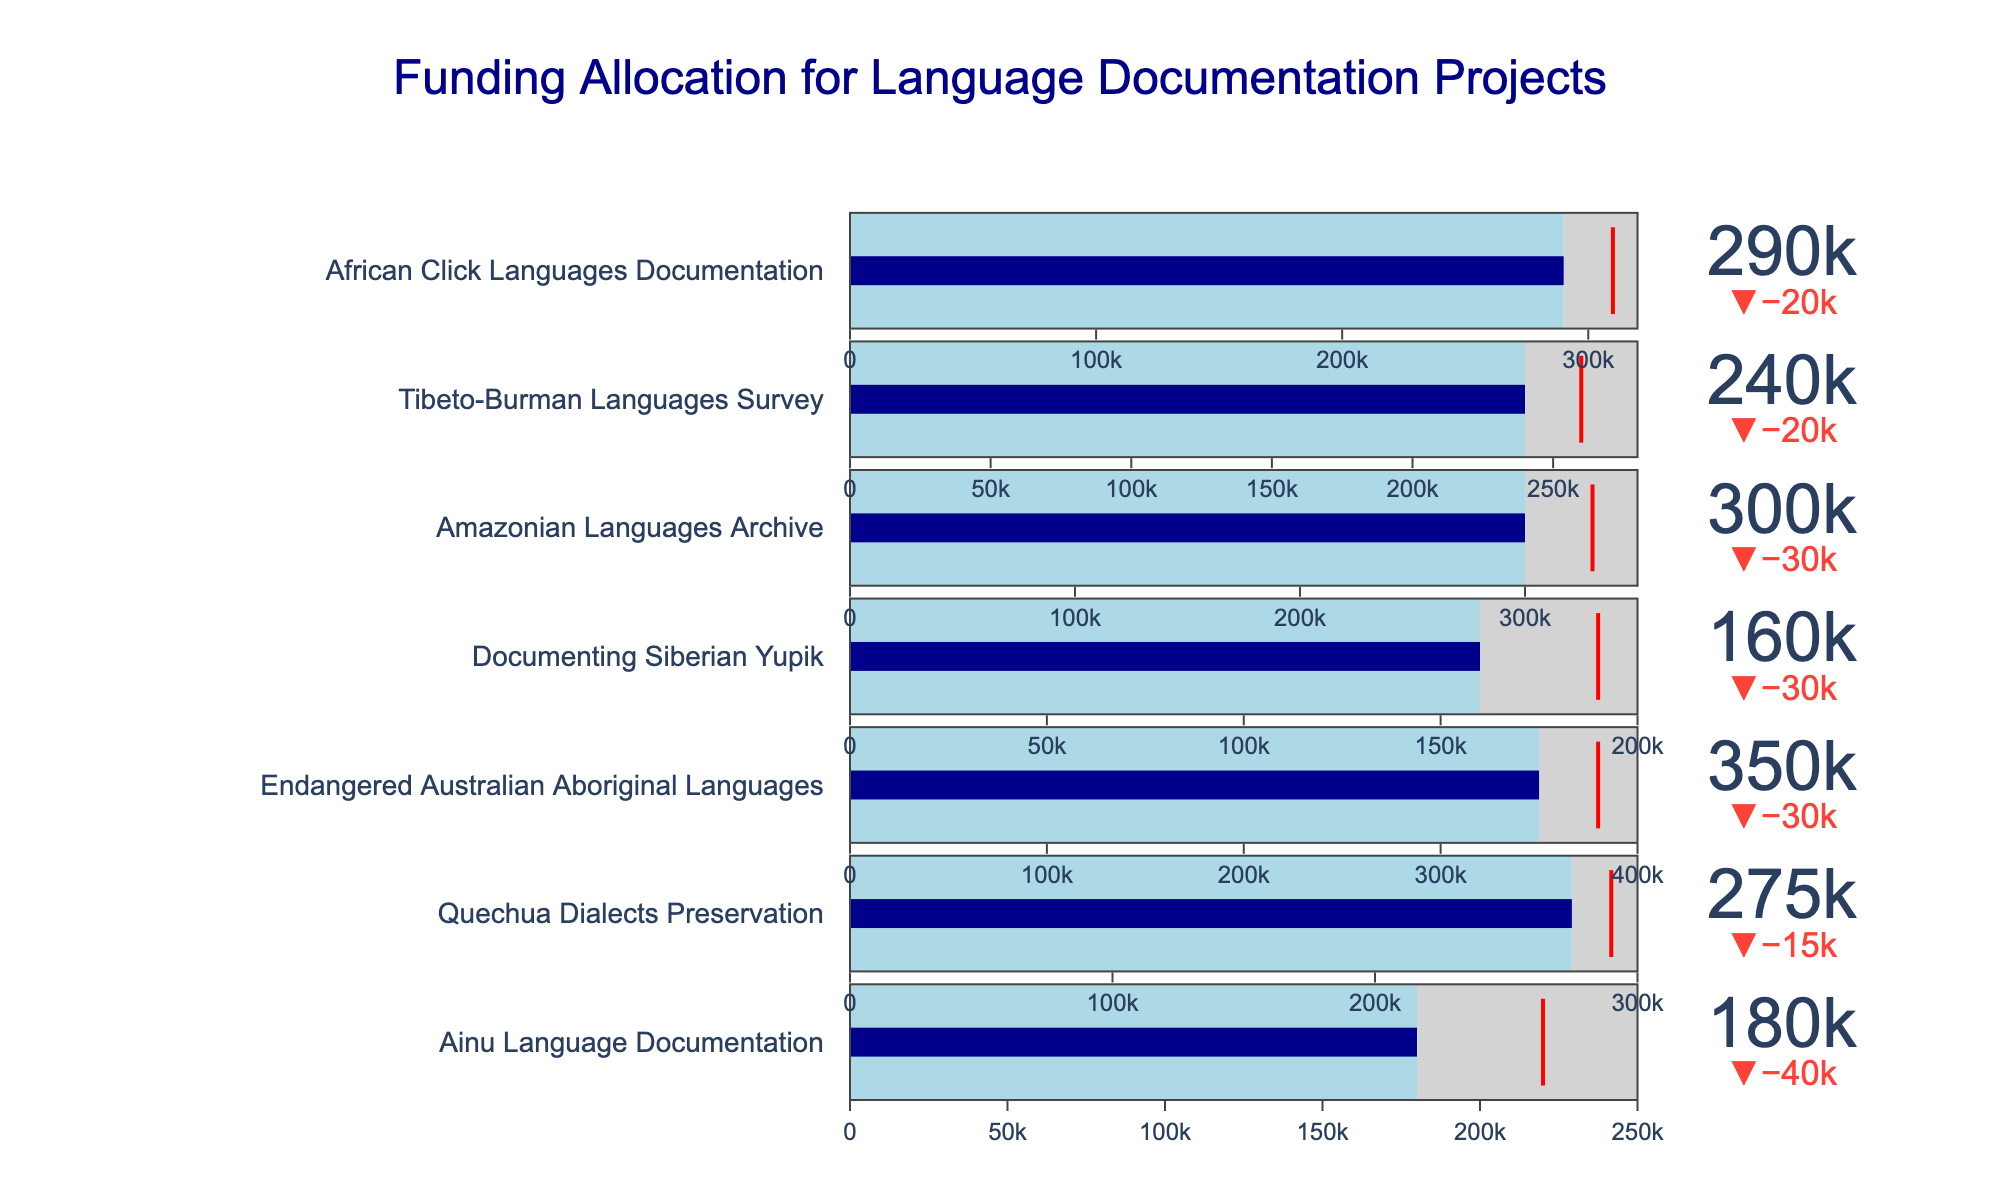How many projects are displayed in the bullet chart? Count the number of individual projects listed in the chart. There are 7 projects shown: Ainu Language Documentation, Quechua Dialects Preservation, Endangered Australian Aboriginal Languages, Documenting Siberian Yupik, Amazonian Languages Archive, Tibeto-Burman Languages Survey, and African Click Languages Documentation.
Answer: 7 Which project received the highest actual funding? Look at the actual funding values for each project and identify the highest one. Endangered Australian Aboriginal Languages received the highest actual funding of $350,000.
Answer: Endangered Australian Aboriginal Languages Which project is closest to its target funding? Calculate the difference between actual funding and target funding for each project, then identify the smallest difference. Quechua Dialects Preservation has the smallest difference of $15,000 ($275,000 actual vs. $290,000 target).
Answer: Quechua Dialects Preservation What is the total proposed budget across all projects? Sum up the Proposed Budget values for all projects: $250,000 + $300,000 + $400,000 + $200,000 + $350,000 + $280,000 + $320,000. The total is $2,100,000.
Answer: $2,100,000 Which projects exceeded their target funding? Compare actual funding to target funding for each project and identify the ones where actual funding is greater than or equal to target funding. No project surpassed its target funding.
Answer: None For the Amazonian Languages Archive, how much less was the actual funding compared to the proposed budget? Subtract the actual funding from the proposed budget for the Amazonian Languages Archive: $350,000 - $300,000 = $50,000.
Answer: $50,000 Which project has the largest gap between its actual funding and proposed budget? Calculate the difference between actual funding and proposed budget for all projects and identify the largest difference. Endangered Australian Aboriginal Languages has the largest gap of $50,000 ($400,000 proposed - $350,000 actual).
Answer: Endangered Australian Aboriginal Languages What is the average actual funding for all projects? Sum up the actual funding values for all projects and divide by the number of projects: ($180,000 + $275,000 + $350,000 + $160,000 + $300,000 + $240,000 + $290,000) / 7. The average is $255,000.
Answer: $255,000 How does the African Click Languages Documentation's outlined threshold compare to its actual funding? Compare the threshold value (target funding) with the actual funding. The target funding for African Click Languages Documentation is $310,000, and the actual funding is $290,000. The actual funding is $20,000 less than the target funding.
Answer: $20,000 less 